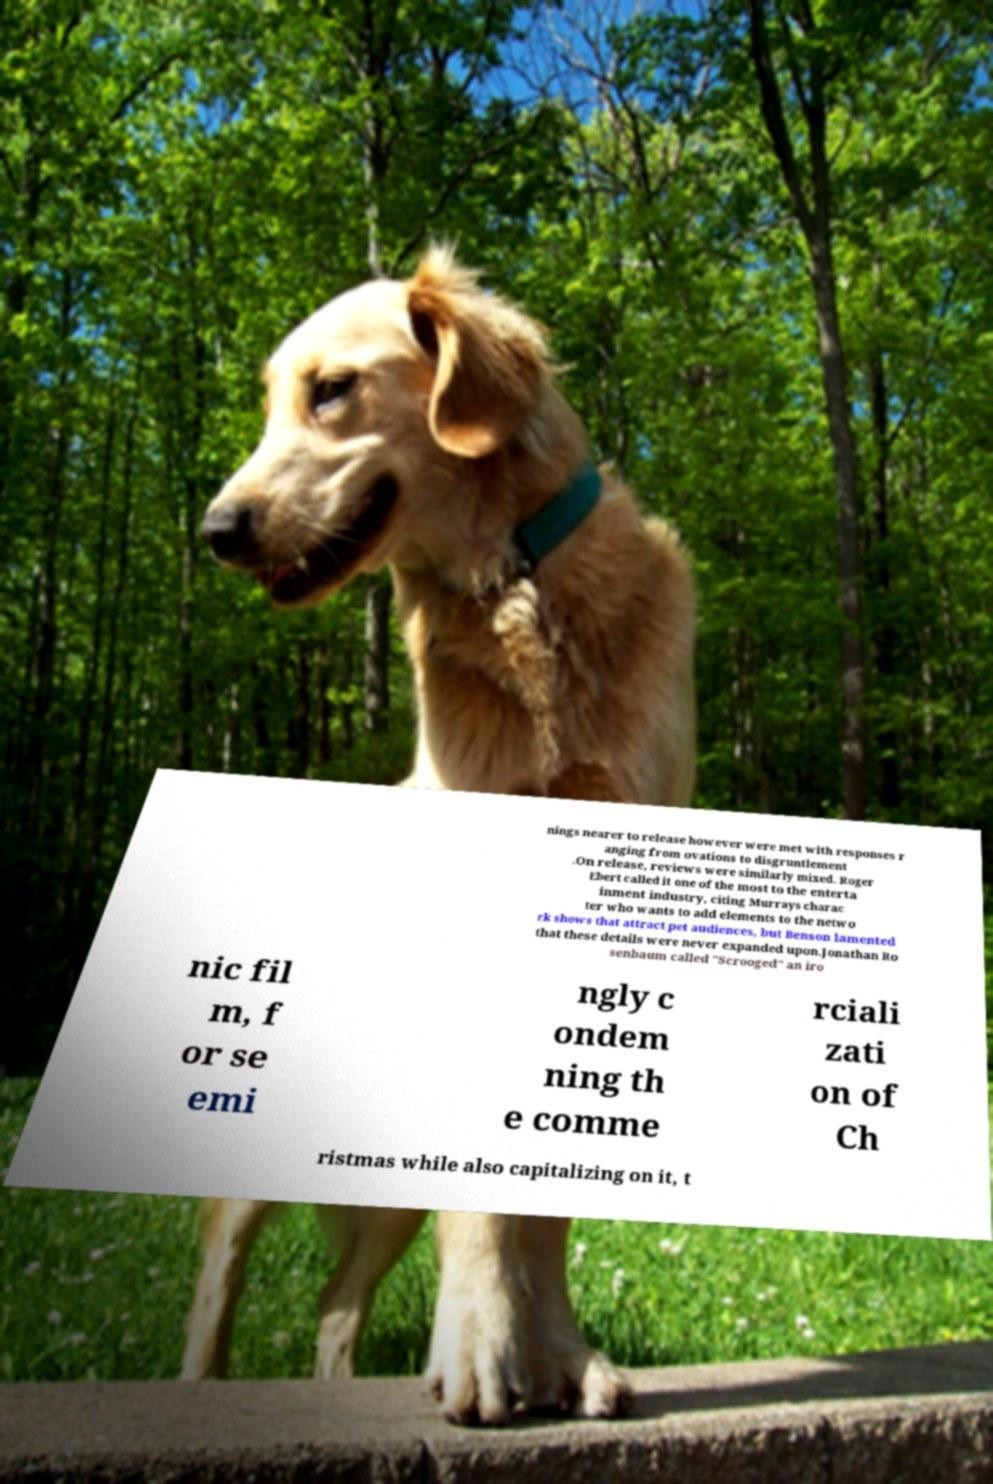There's text embedded in this image that I need extracted. Can you transcribe it verbatim? nings nearer to release however were met with responses r anging from ovations to disgruntlement .On release, reviews were similarly mixed. Roger Ebert called it one of the most to the enterta inment industry, citing Murrays charac ter who wants to add elements to the netwo rk shows that attract pet audiences, but Benson lamented that these details were never expanded upon.Jonathan Ro senbaum called "Scrooged" an iro nic fil m, f or se emi ngly c ondem ning th e comme rciali zati on of Ch ristmas while also capitalizing on it, t 